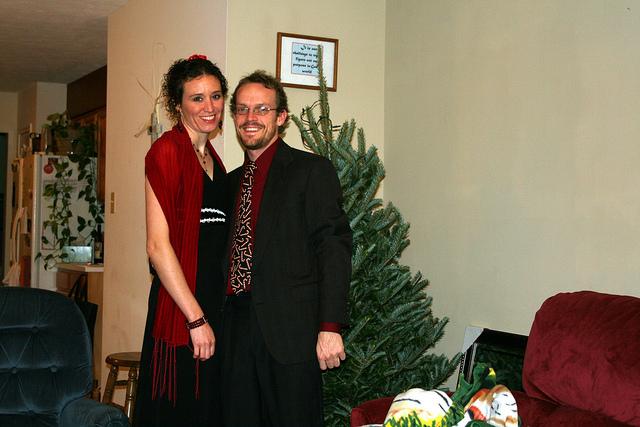Is he talking on the phone?
Quick response, please. No. Is the necktie on right place?
Write a very short answer. Yes. Is there a plant on the refrigerator?
Short answer required. Yes. Is this a birthday cake?
Short answer required. No. How many people in the photo?
Give a very brief answer. 2. How many dresses are there?
Be succinct. 1. How many people have red shirts?
Be succinct. 1. What is on the woman's neck?
Give a very brief answer. Necklace. Is the man eating?
Concise answer only. No. What is around the woman's neck?
Concise answer only. Scarf. Are these two possibly father and son?
Short answer required. No. What color is the couch?
Answer briefly. Red. What three colors of ornaments are on the tree?
Quick response, please. No. What event are the people in the picture celebrating?
Write a very short answer. Christmas. What are they doing right now?
Write a very short answer. Posing. What is in his mouth?
Concise answer only. Teeth. What is the man holding?
Be succinct. Woman. Does the man have curly hair?
Keep it brief. Yes. How many real people are pictured?
Answer briefly. 2. Do the colors in the man's tie match his shirt and/or slacks?
Give a very brief answer. Yes. How many party hats?
Write a very short answer. 0. Are these people looking at a TV screen?
Short answer required. No. Is there furniture?
Give a very brief answer. Yes. Are these senior citizens?
Keep it brief. No. Are these plants in the picture real or fake?
Short answer required. Real. 